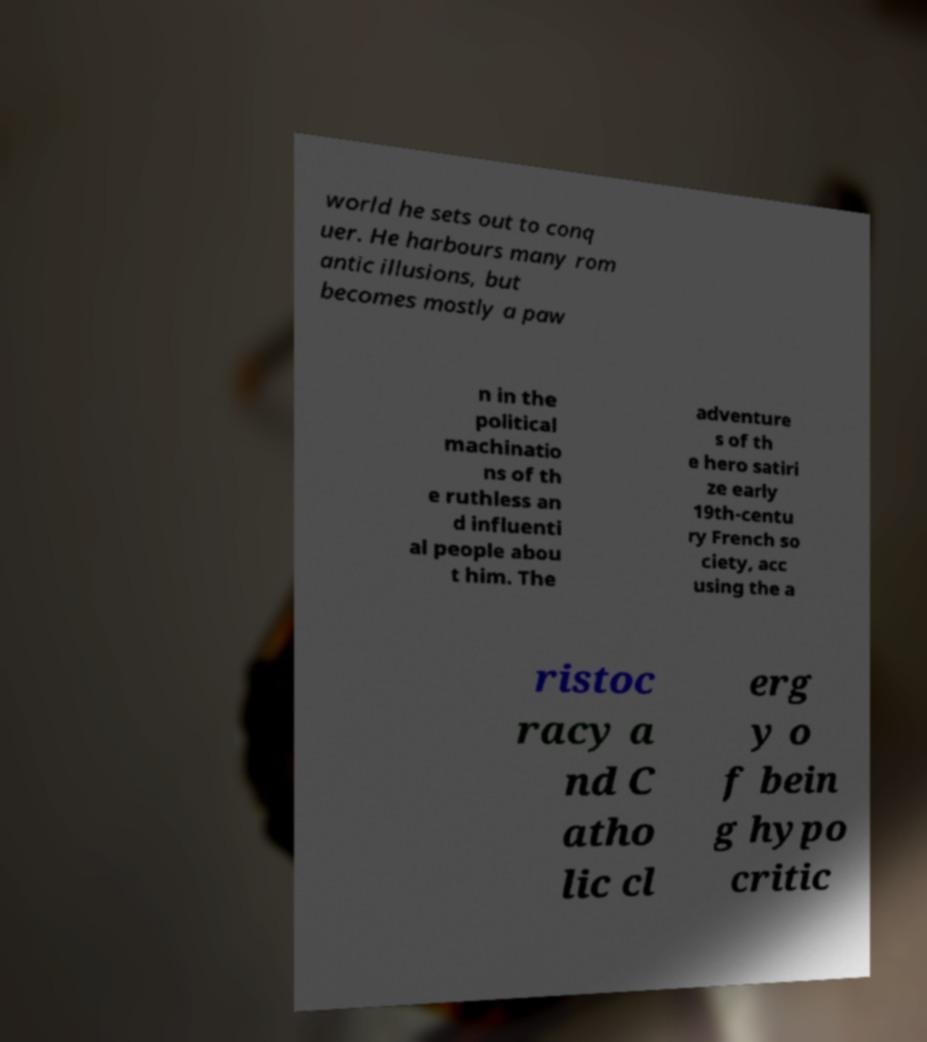Can you accurately transcribe the text from the provided image for me? world he sets out to conq uer. He harbours many rom antic illusions, but becomes mostly a paw n in the political machinatio ns of th e ruthless an d influenti al people abou t him. The adventure s of th e hero satiri ze early 19th-centu ry French so ciety, acc using the a ristoc racy a nd C atho lic cl erg y o f bein g hypo critic 